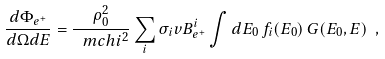<formula> <loc_0><loc_0><loc_500><loc_500>\frac { d \Phi _ { e ^ { + } } } { d \Omega d E } = \frac { \rho _ { 0 } ^ { 2 } } { \ m c h i ^ { 2 } } \sum _ { i } \sigma _ { i } v B _ { e ^ { + } } ^ { i } \int d E _ { 0 } \, f _ { i } ( E _ { 0 } ) \, G ( E _ { 0 } , E ) \ ,</formula> 